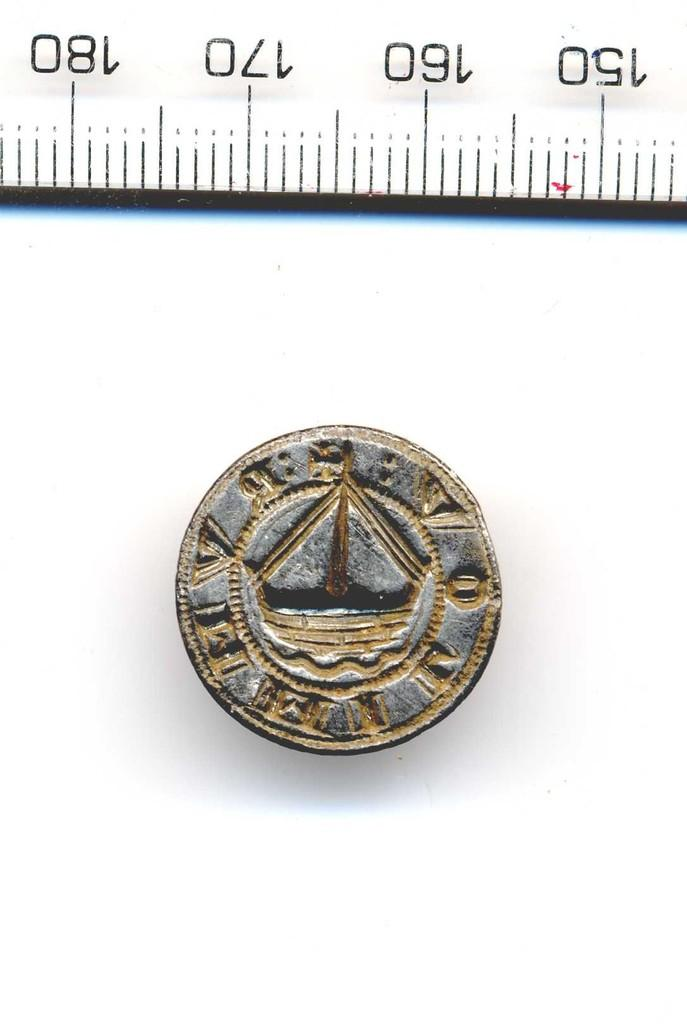<image>
Create a compact narrative representing the image presented. A coin sits next to a measuring tape near the 160 mark. 